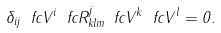<formula> <loc_0><loc_0><loc_500><loc_500>\delta _ { i j } \ f c { V } ^ { i } \ f c { R } ^ { j } _ { k l m } \ f c { V } ^ { k } \ f c { V } ^ { l } = 0 .</formula> 